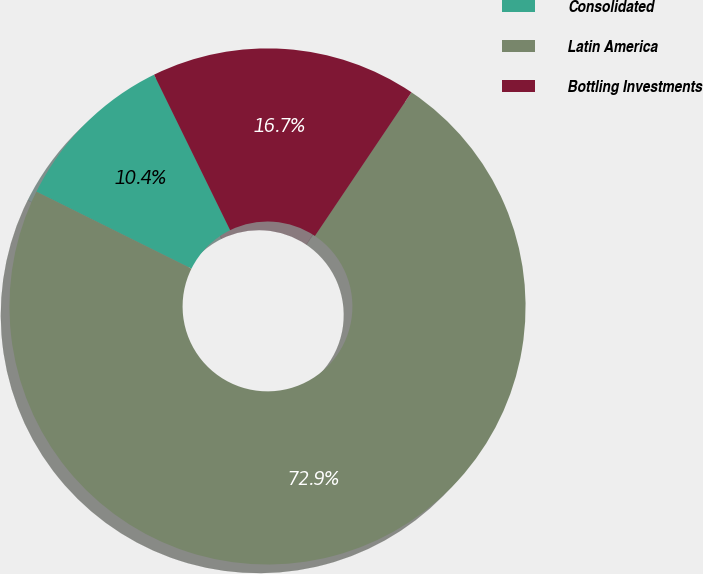<chart> <loc_0><loc_0><loc_500><loc_500><pie_chart><fcel>Consolidated<fcel>Latin America<fcel>Bottling Investments<nl><fcel>10.42%<fcel>72.92%<fcel>16.67%<nl></chart> 